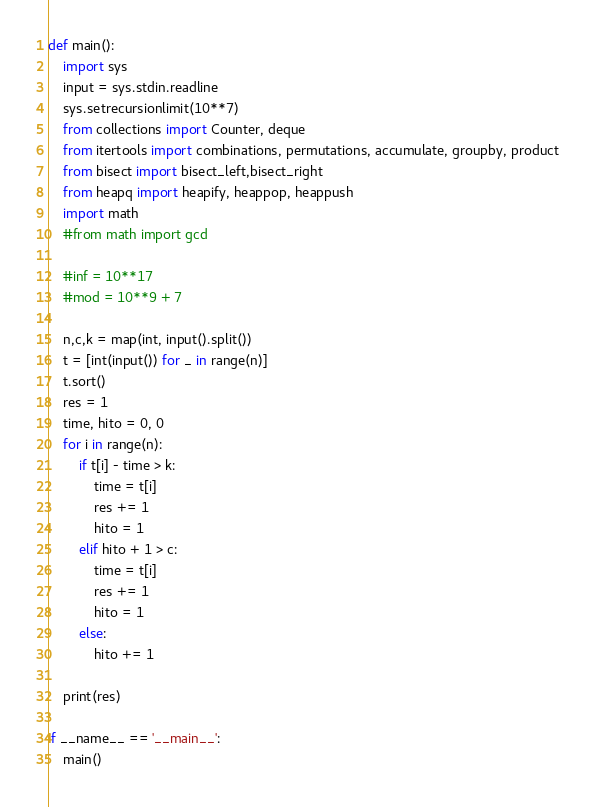Convert code to text. <code><loc_0><loc_0><loc_500><loc_500><_Python_>def main():
    import sys
    input = sys.stdin.readline
    sys.setrecursionlimit(10**7)
    from collections import Counter, deque
    from itertools import combinations, permutations, accumulate, groupby, product
    from bisect import bisect_left,bisect_right
    from heapq import heapify, heappop, heappush
    import math
    #from math import gcd

    #inf = 10**17
    #mod = 10**9 + 7

    n,c,k = map(int, input().split())
    t = [int(input()) for _ in range(n)]
    t.sort()
    res = 1
    time, hito = 0, 0
    for i in range(n):
        if t[i] - time > k:
            time = t[i]
            res += 1
            hito = 1
        elif hito + 1 > c:
            time = t[i]
            res += 1
            hito = 1
        else:
            hito += 1

    print(res)

if __name__ == '__main__':
    main()</code> 